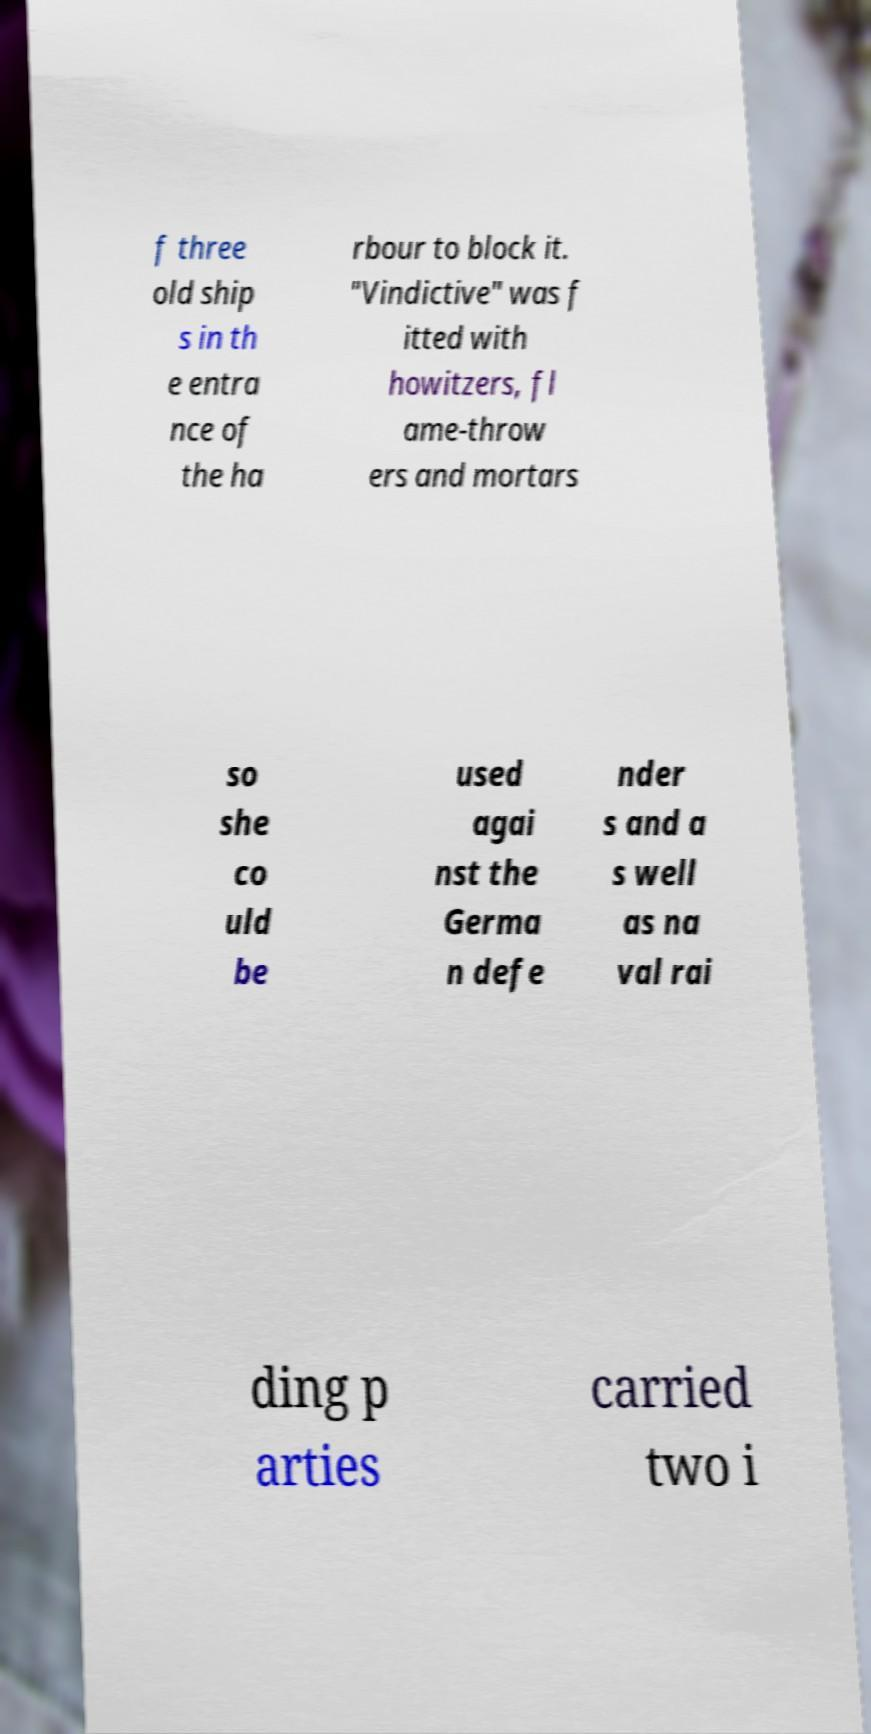Could you extract and type out the text from this image? f three old ship s in th e entra nce of the ha rbour to block it. "Vindictive" was f itted with howitzers, fl ame-throw ers and mortars so she co uld be used agai nst the Germa n defe nder s and a s well as na val rai ding p arties carried two i 